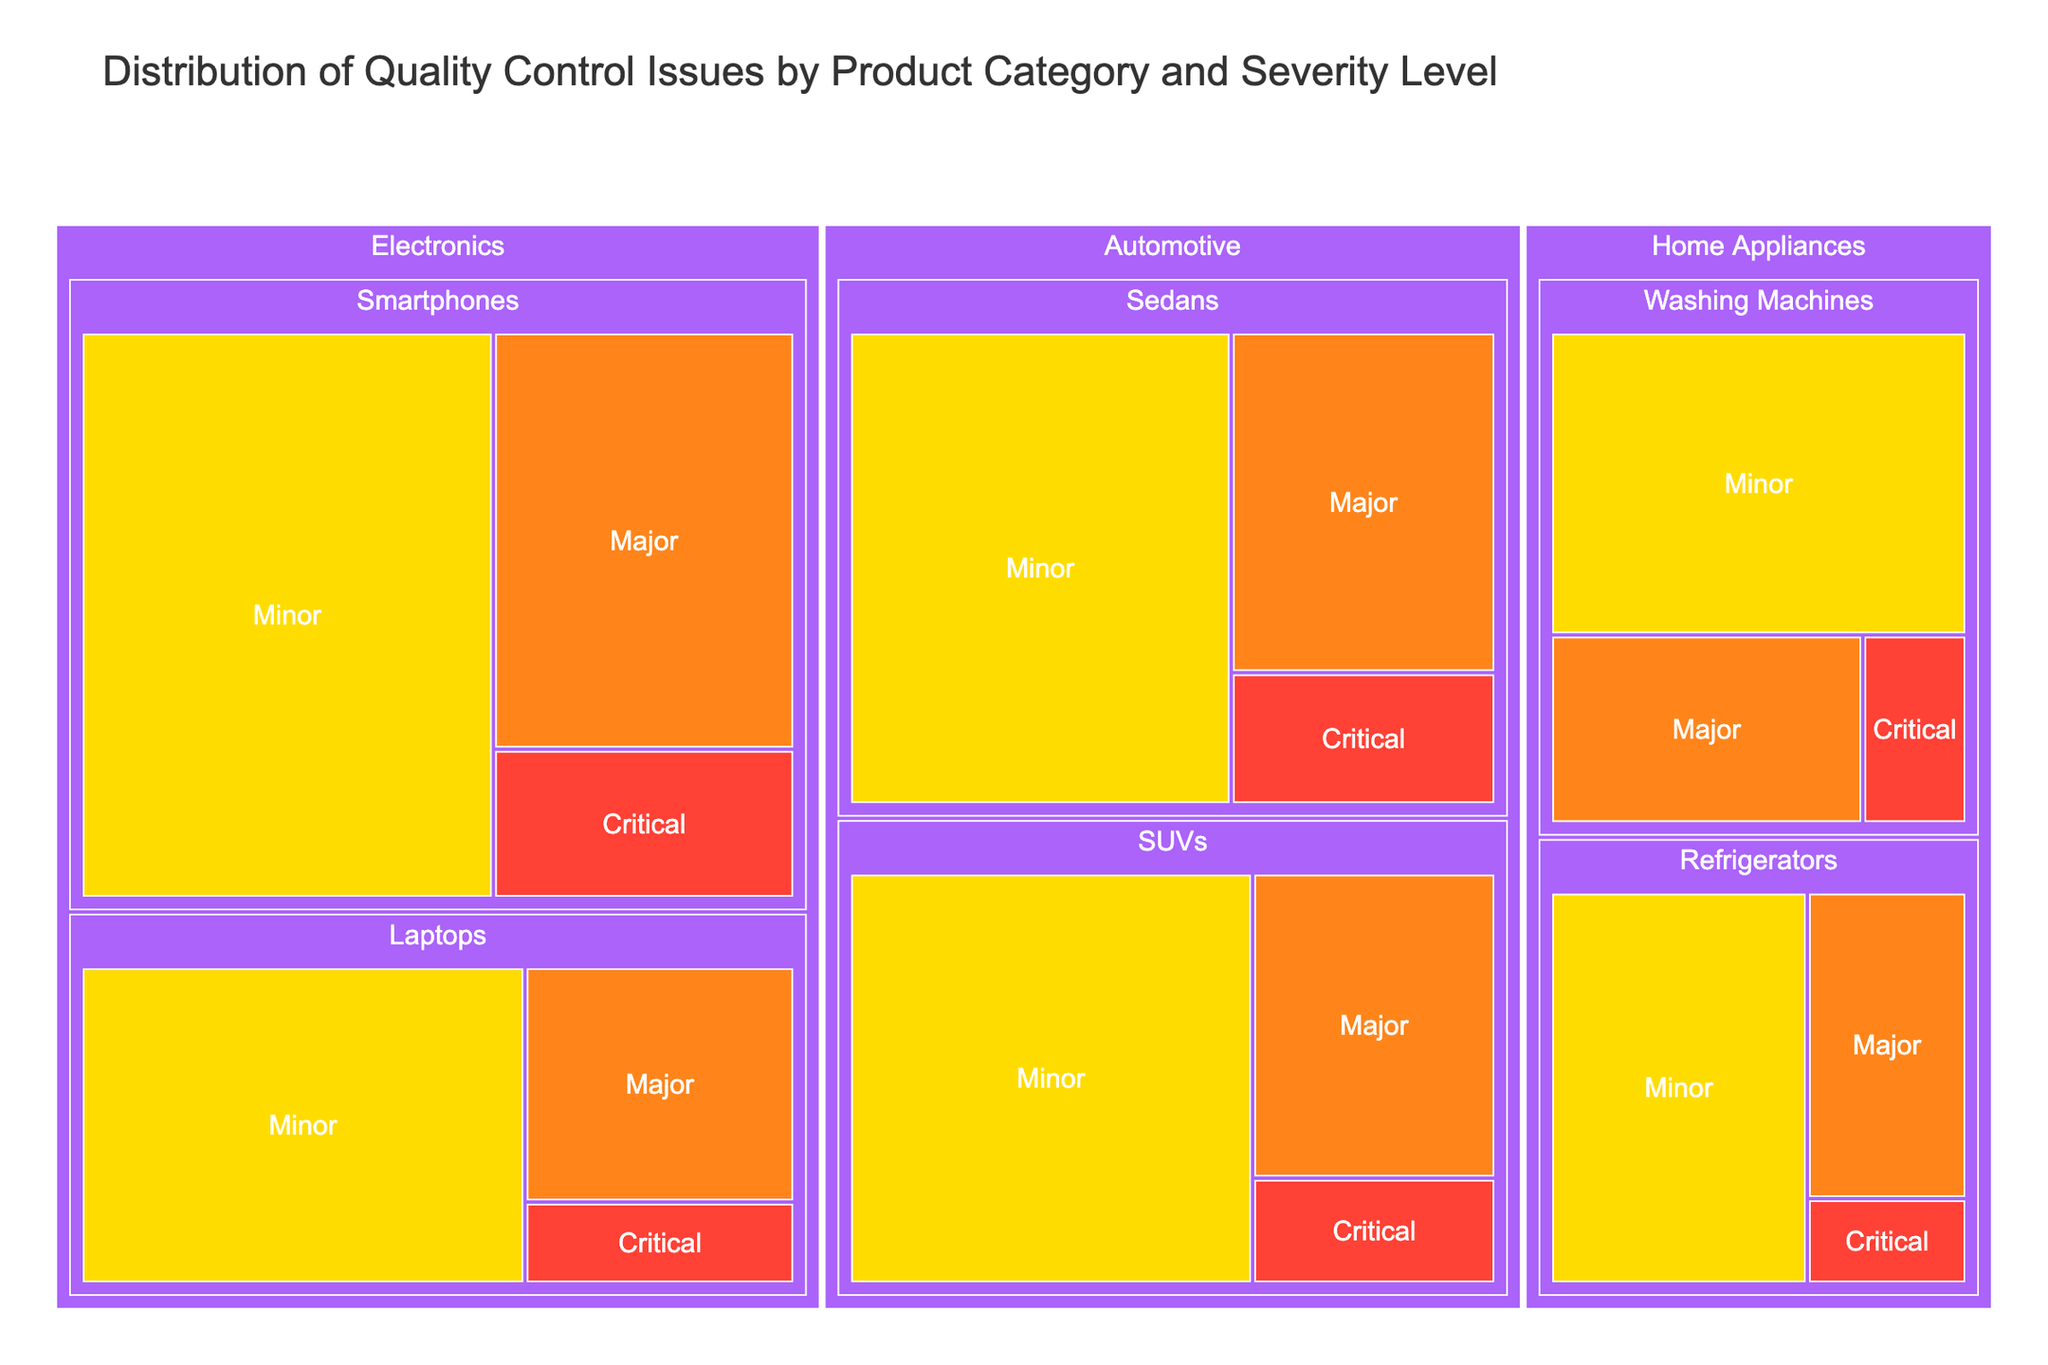What's the title of the treemap? The title is displayed at the top of the treemap and is usually used to summarize the main topic of the visualization.
Answer: Distribution of Quality Control Issues by Product Category and Severity Level How many quality control issues are there in the Smartphones subcategory? To find the total number of quality control issues in the Smartphones subcategory, sum up the counts across all severity levels (Critical, Major, Minor). 15 (Critical) + 42 (Major) + 78 (Minor) = 135
Answer: 135 Which subcategory within the Automotive category has more Minor issues, Sedans or SUVs? Compare the number of Minor issues between the Sedans and SUVs subcategories within the Automotive category. Sedans have 62 Minor issues and SUVs have 58 Minor issues, so Sedans have more.
Answer: Sedans Is the proportion of Critical issues greater in Electronics or Home Appliances? Calculate the total number of Critical issues in each category. Electronics: 15 (Smartphones) + 8 (Laptops) = 23. Home Appliances: 5 (Refrigerators) + 7 (Washing Machines) = 12. Compare these totals. 23 is greater than 12.
Answer: Electronics Which severity level has the highest count within the Home Appliances category? Count the total number of issues for each severity level within the Home Appliances category and identify the highest. Minor: 37 (Refrigerators) + 45 (Washing Machines) = 82, Major: 18 (Refrigerators) + 21 (Washing Machines) = 39, Critical: 5 (Refrigerators) + 7 (Washing Machines) = 12. The Minor level has the highest count.
Answer: Minor What is the total number of Major issues across all categories? Sum the number of Major issues across all subcategories: 42 (Smartphones) + 23 (Laptops) + 18 (Refrigerators) + 21 (Washing Machines) + 31 (Sedans) + 26 (SUVs) = 161
Answer: 161 Which subcategory has the lowest number of Critical issues? Compare the number of Critical issues across all subcategories. The lowest number is in the Refrigerators subcategory with 5 issues.
Answer: Refrigerators How does the number of Minor issues in Laptops compare to the number of Minor issues in Washing Machines? Compare the counts directly. Laptops have 51 Minor issues, while Washing Machines have 45. Hence, Laptops have more Minor issues than Washing Machines.
Answer: Laptops What percentage of the total quality control issues in the Automotive category are Critical issues? First, find the total number of issues in the Automotive category. Critical: 12 (Sedans) + 9 (SUVs) = 21, Major: 31 (Sedans) + 26 (SUVs) = 57, Minor: 62 (Sedans) + 58 (SUVs) = 120. Total issues = 21 + 57 + 120 = 198. The percentage of Critical issues is (21 / 198) * 100 ≈ 10.6%.
Answer: 10.6% In which category is the difference between the number of Critical and Major issues the greatest? Calculate the difference between the Critical and Major issues for each category. Electronics: 23 Critical, 65 Major, 65 - 23 = 42. Home Appliances: 12 Critical, 39 Major, 39 - 12 = 27. Automotive: 21 Critical, 57 Major, 57 - 21 = 36. Electronics has the greatest difference of 42.
Answer: Electronics 